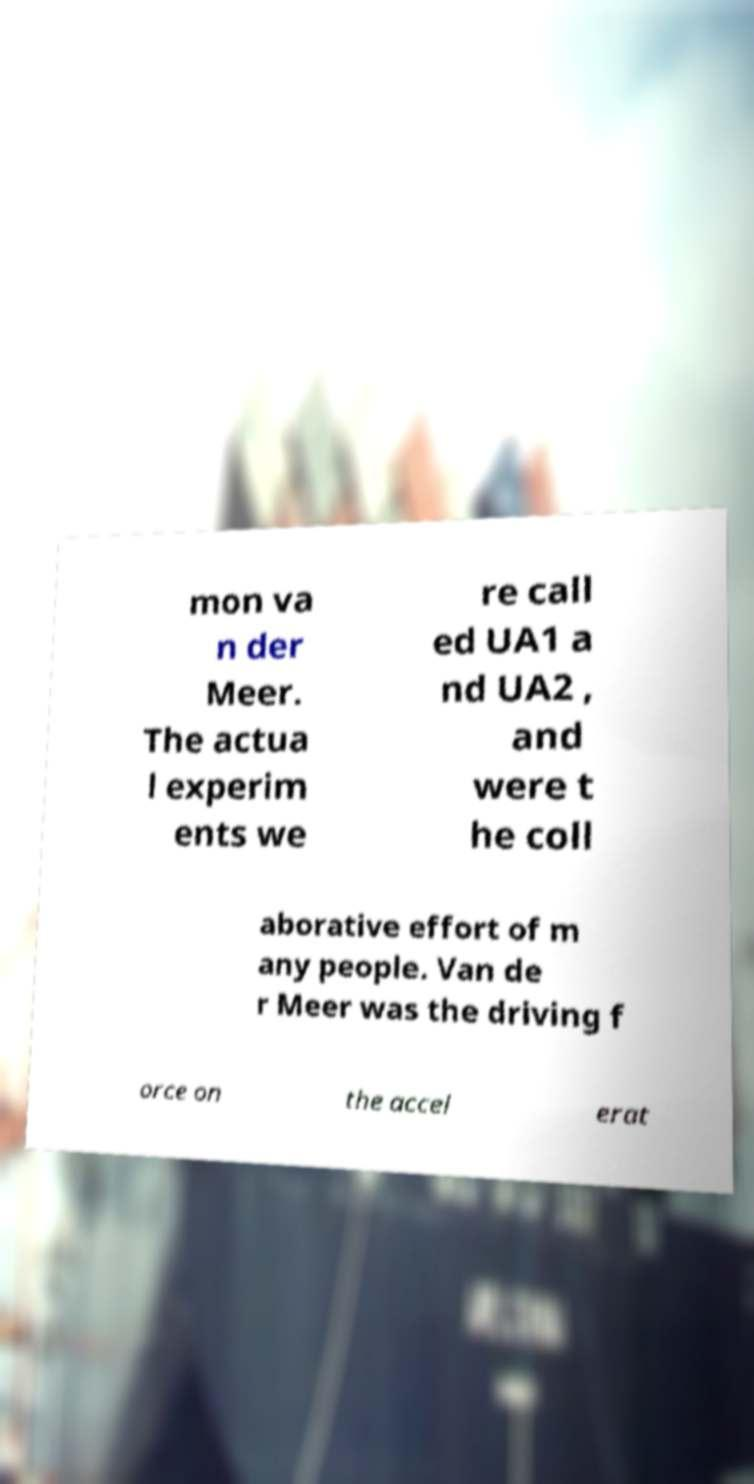Can you accurately transcribe the text from the provided image for me? mon va n der Meer. The actua l experim ents we re call ed UA1 a nd UA2 , and were t he coll aborative effort of m any people. Van de r Meer was the driving f orce on the accel erat 